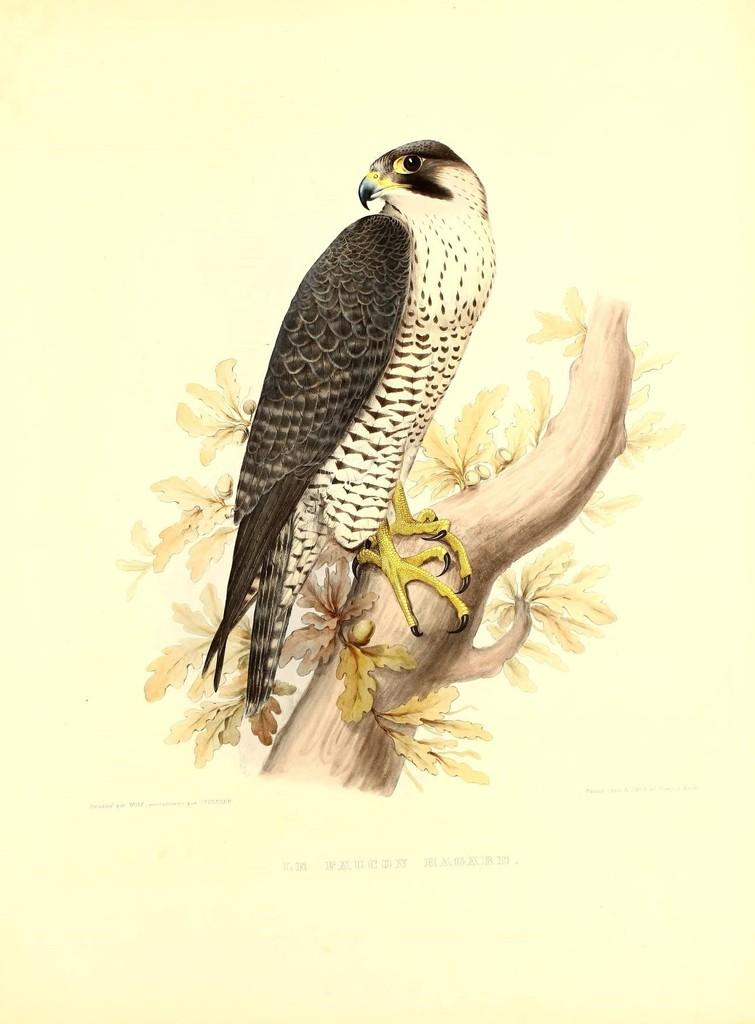What type of artwork is depicted in the image? The image appears to be a painting. What animal can be seen in the painting? There is an eagle in the image. Where is the eagle located in the painting? The eagle is standing on a branch of a tree. What type of health advice is the eagle offering in the painting? The eagle is not offering any health advice in the painting; it is simply depicted as standing on a branch of a tree. 